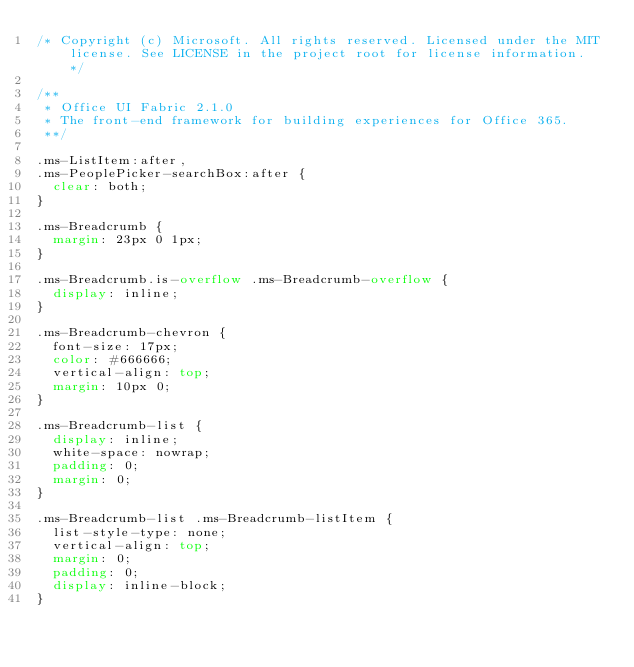<code> <loc_0><loc_0><loc_500><loc_500><_CSS_>/* Copyright (c) Microsoft. All rights reserved. Licensed under the MIT license. See LICENSE in the project root for license information. */

/**
 * Office UI Fabric 2.1.0
 * The front-end framework for building experiences for Office 365.
 **/

.ms-ListItem:after,
.ms-PeoplePicker-searchBox:after {
  clear: both;
}

.ms-Breadcrumb {
  margin: 23px 0 1px;
}

.ms-Breadcrumb.is-overflow .ms-Breadcrumb-overflow {
  display: inline;
}

.ms-Breadcrumb-chevron {
  font-size: 17px;
  color: #666666;
  vertical-align: top;
  margin: 10px 0;
}

.ms-Breadcrumb-list {
  display: inline;
  white-space: nowrap;
  padding: 0;
  margin: 0;
}

.ms-Breadcrumb-list .ms-Breadcrumb-listItem {
  list-style-type: none;
  vertical-align: top;
  margin: 0;
  padding: 0;
  display: inline-block;
}
</code> 